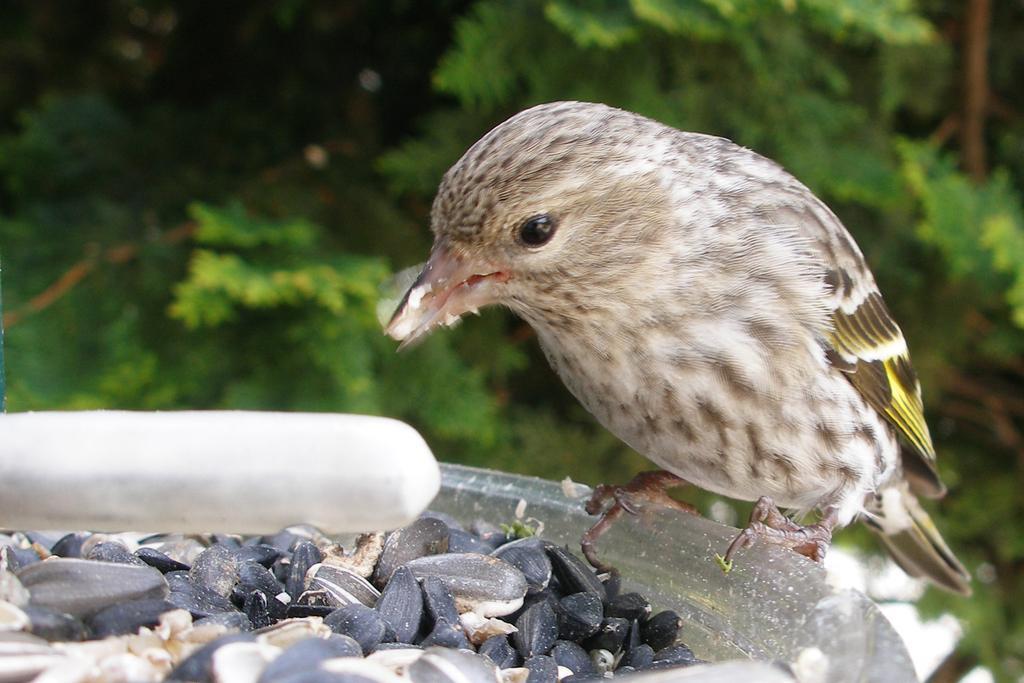Can you describe this image briefly? In the foreground, I can see a bird is sitting on an object and sunflower seeds I can see. In the background, I can see trees. This image taken, maybe during a day. 